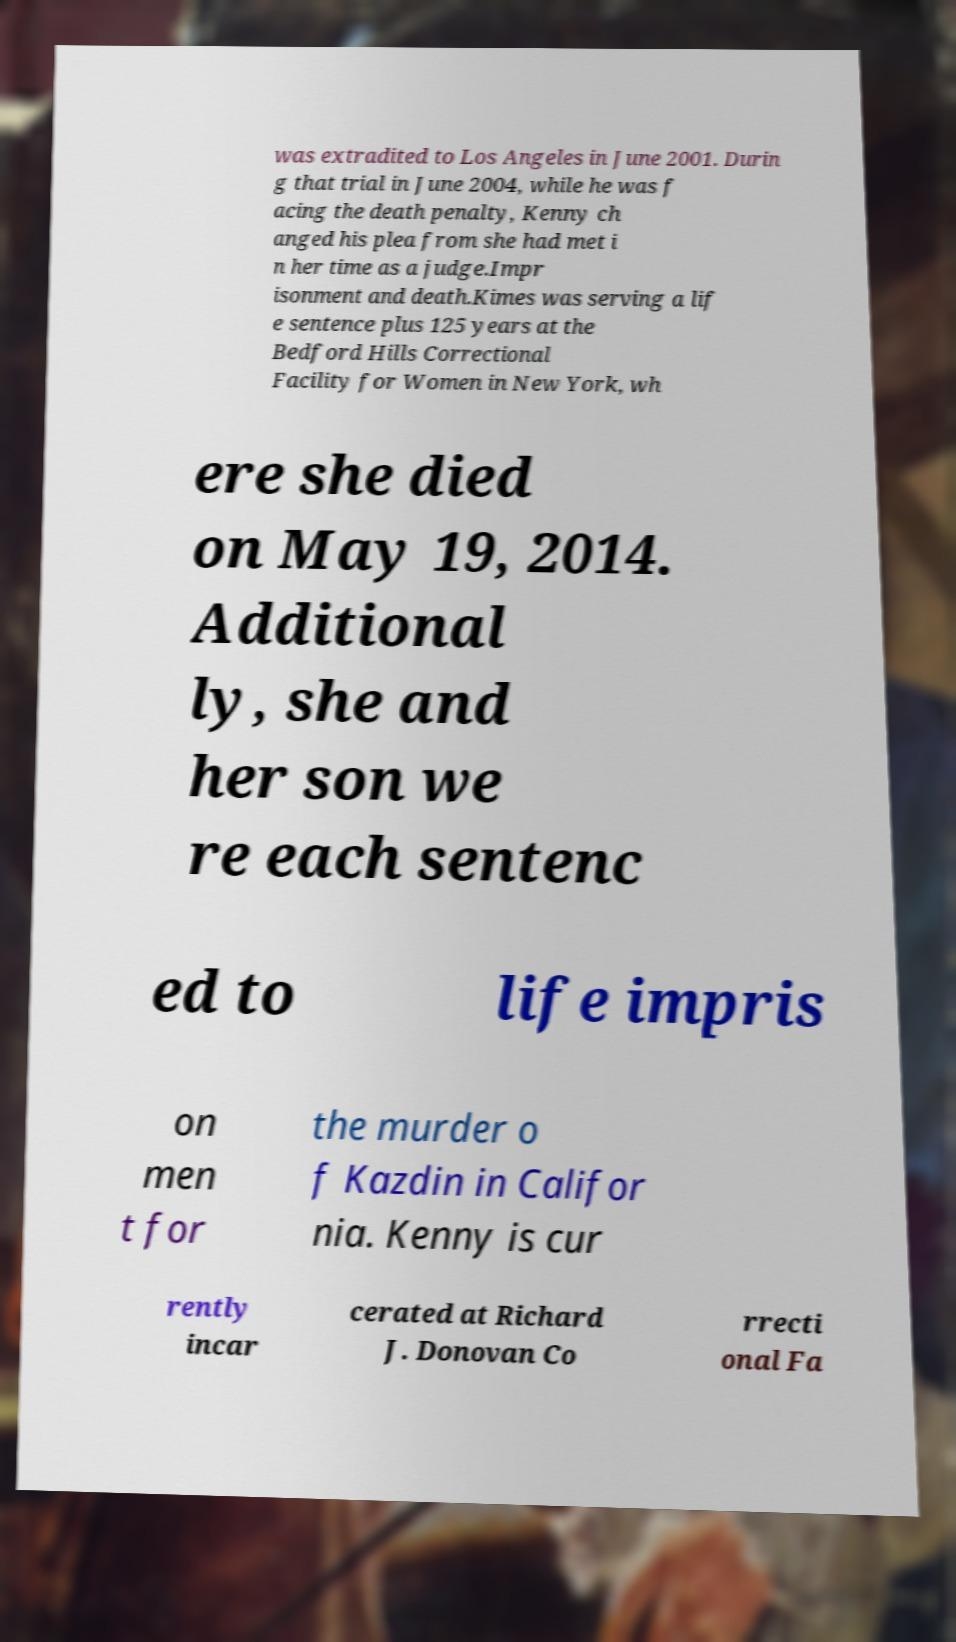Can you accurately transcribe the text from the provided image for me? was extradited to Los Angeles in June 2001. Durin g that trial in June 2004, while he was f acing the death penalty, Kenny ch anged his plea from she had met i n her time as a judge.Impr isonment and death.Kimes was serving a lif e sentence plus 125 years at the Bedford Hills Correctional Facility for Women in New York, wh ere she died on May 19, 2014. Additional ly, she and her son we re each sentenc ed to life impris on men t for the murder o f Kazdin in Califor nia. Kenny is cur rently incar cerated at Richard J. Donovan Co rrecti onal Fa 